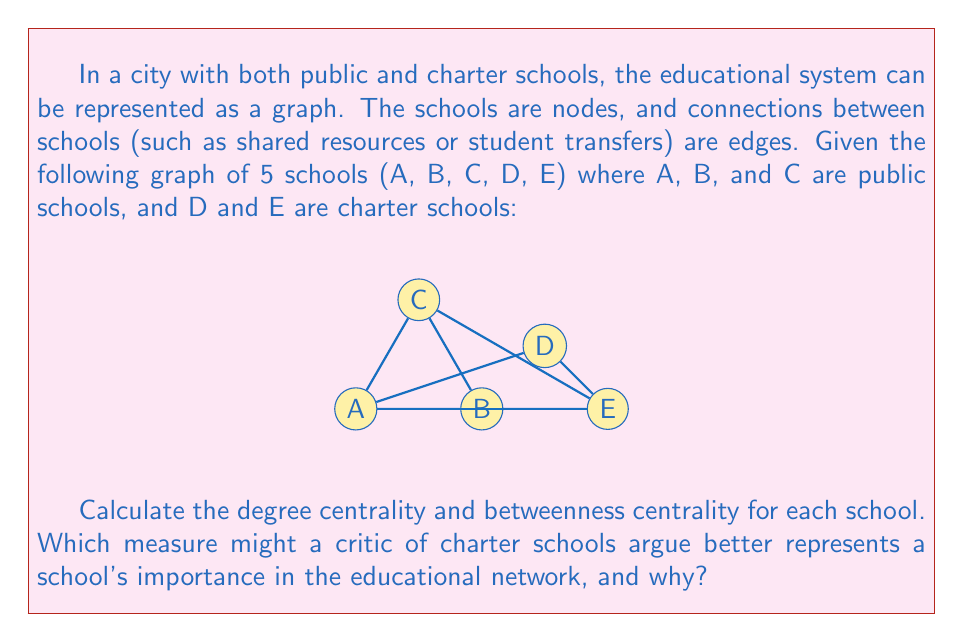Provide a solution to this math problem. To answer this question, we need to calculate two centrality measures for each school: degree centrality and betweenness centrality.

1. Degree Centrality:
Degree centrality is simply the number of connections a node has.

A: 4 connections
B: 3 connections
C: 3 connections
D: 1 connection
E: 4 connections

2. Betweenness Centrality:
Betweenness centrality measures how often a node appears on shortest paths between other nodes.

First, we need to count the number of shortest paths between all pairs of nodes:

A-B: 1, A-C: 1, A-D: 1, A-E: 1
B-C: 1, B-D: 2 (B-D, B-A-D), B-E: 1
C-D: 2 (C-A-D, C-E-D), C-E: 1
D-E: 1

Now, we count how many of these shortest paths pass through each node (excluding paths that start or end at the node):

A: (B-D: 1), (C-D: 1) = 2
B: (A-E: 1), (C-E: 1/2) = 1.5
C: (A-E: 1/2), (B-D: 1/2) = 1
D: 0
E: (A-C: 1/2), (B-C: 1/2), (A-D: 1/2), (B-D: 1/2) = 2

Normalizing these values by dividing by the total number of shortest paths between all pairs of nodes (10):

A: 2/10 = 0.2
B: 1.5/10 = 0.15
C: 1/10 = 0.1
D: 0/10 = 0
E: 2/10 = 0.2

A critic of charter schools might argue that degree centrality better represents a school's importance in the educational network. This is because:

1. Public schools (A, B, C) generally have higher degree centrality than charter schools (D, E), with the exception of E.
2. Degree centrality represents direct connections, which could be interpreted as immediate impact on the local educational community.
3. The high degree centrality of E might be seen as an outlier or as a charter school "stealing" connections from public schools.

On the other hand, betweenness centrality shows that one charter school (E) is equally as important as the most central public school (A) in terms of facilitating connections between other schools. A critic might argue that this measure overemphasizes the role of charter schools in the overall educational network.
Answer: Degree Centrality: A(4), B(3), C(3), D(1), E(4)
Betweenness Centrality: A(0.2), B(0.15), C(0.1), D(0), E(0.2)
A critic might prefer degree centrality as it generally shows higher importance for public schools. 